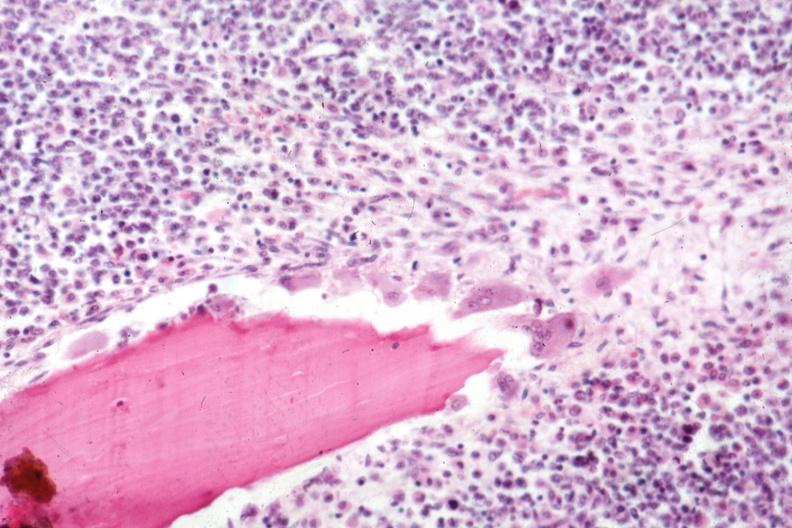what does this image show?
Answer the question using a single word or phrase. Osteoclasts quite well shown marrow diffuse infiltration with malignant lymphoma 